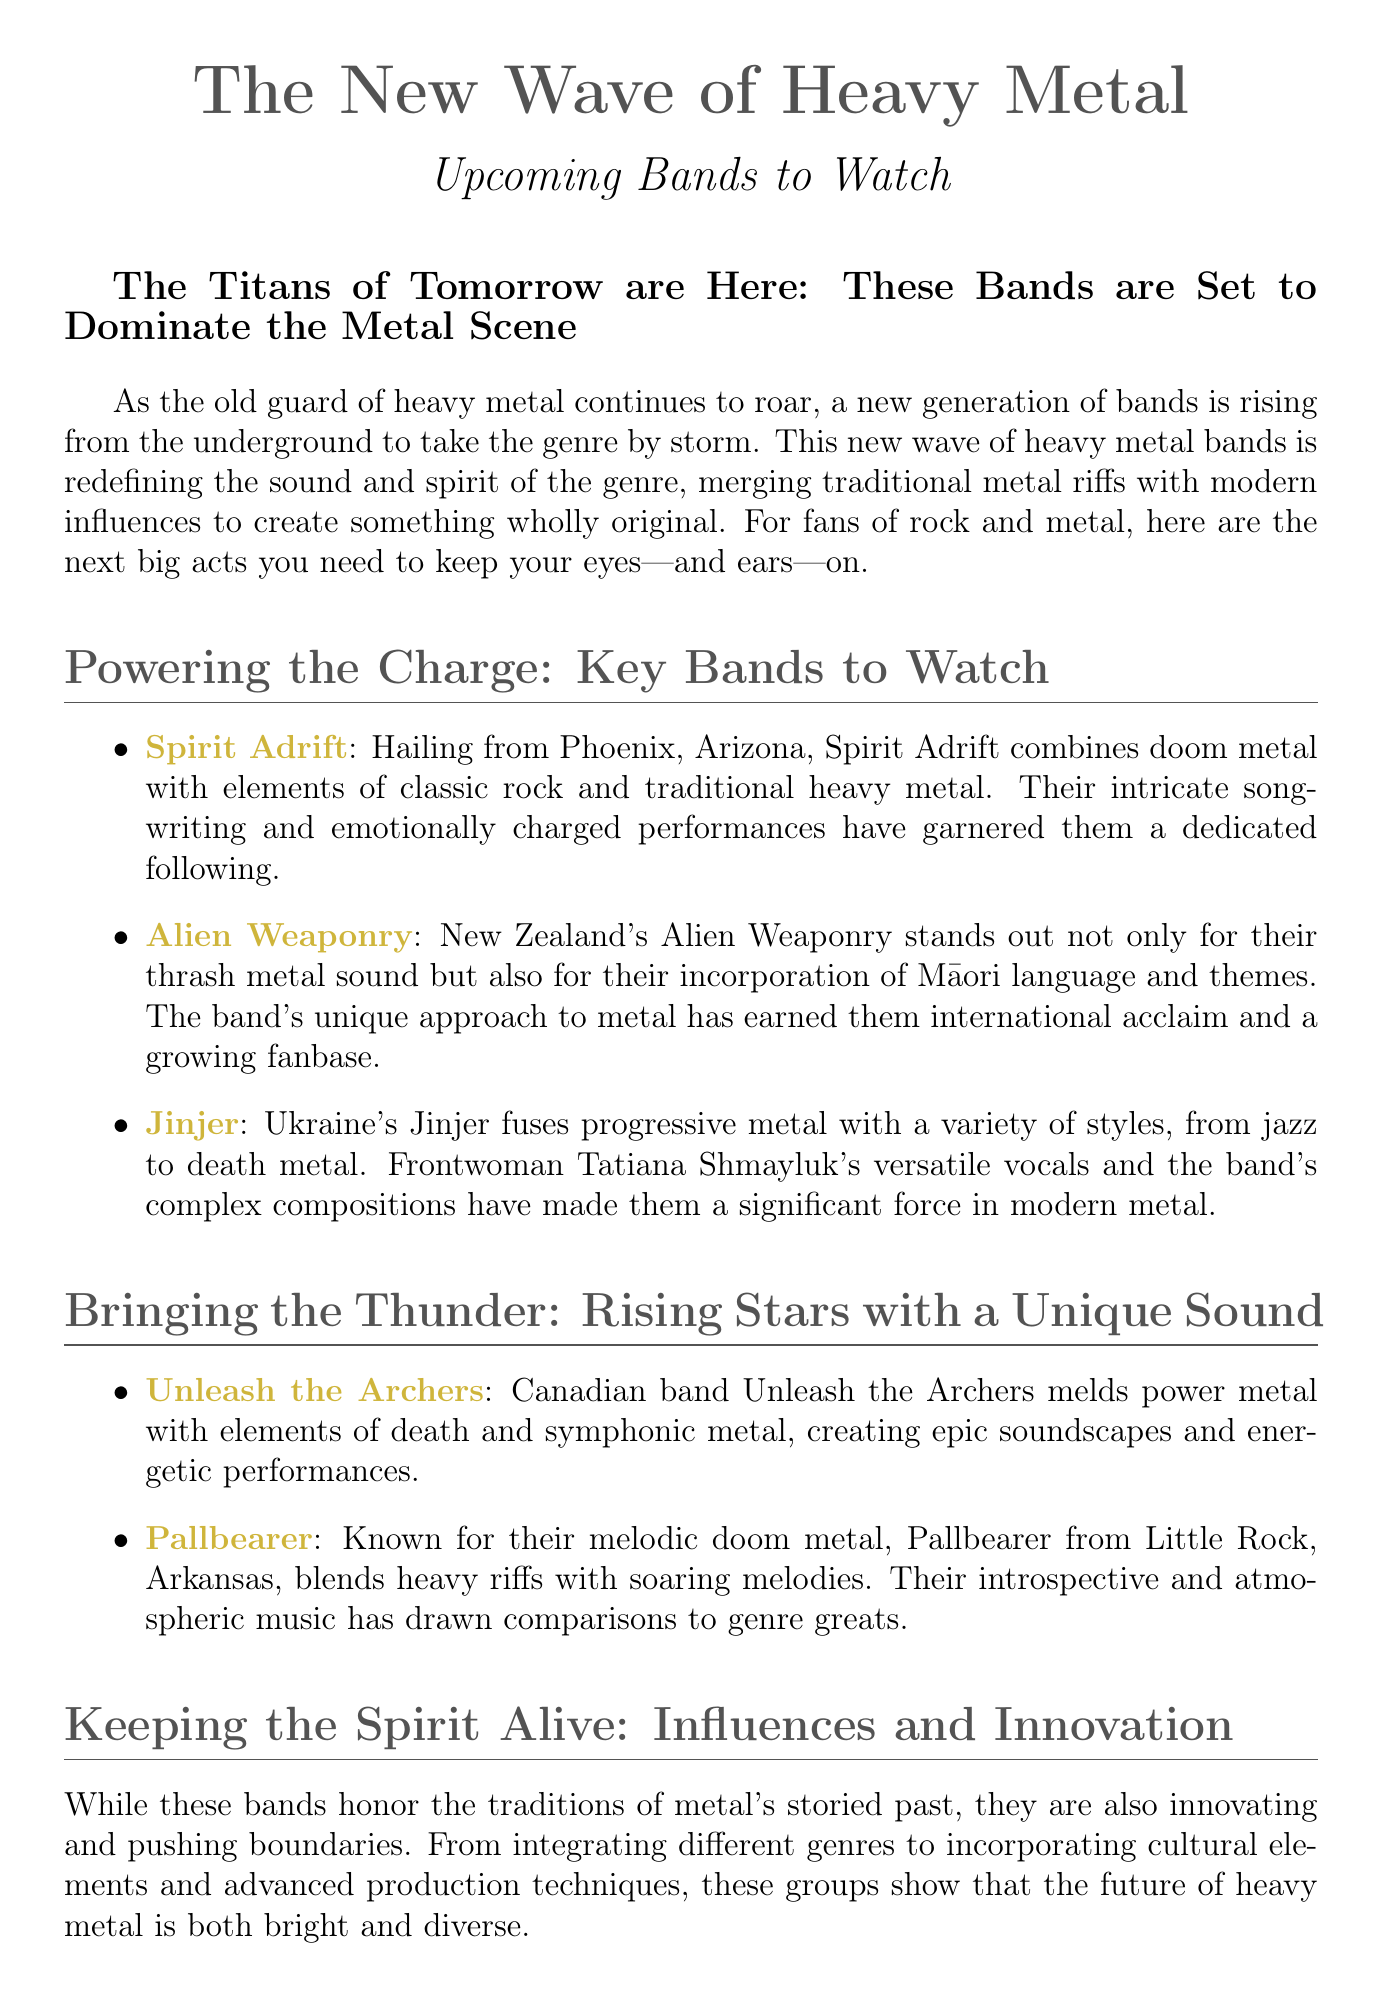What is the title of the press release? The title of the press release is prominently displayed at the top of the document, indicating the focus on the New Wave of Heavy Metal.
Answer: The New Wave of Heavy Metal Which band is mentioned as being from Phoenix, Arizona? The document specifies that Spirit Adrift is hailing from Phoenix, Arizona, making it clear which band is associated with that location.
Answer: Spirit Adrift What genre does Alien Weaponry primarily represent? The press release notes that Alien Weaponry stands out for their thrash metal sound, highlighting the genre they belong to.
Answer: Thrash metal Who is the frontwoman of Jinjer? The document features information about the band's lead vocalist, specifically mentioning her name and role within the group.
Answer: Tatiana Shmayluk Which band is known for melodic doom metal? The press release provides key information on the style of one band, specifically categorizing them by their unique sound within the metal genre.
Answer: Pallbearer What type of sound do Unleash the Archers create? The document describes the sound of Unleash the Archers, indicating their blend of genres that contributes to their musical identity.
Answer: Power metal with elements of death and symphonic metal How does the press release characterize the new wave of heavy metal? The text discusses the new wave and its significance to the genre, emphasizing the themes of innovation and evolution.
Answer: Bright and diverse What elements do these bands incorporate in their sound? The document mentions characteristics that define the new wave, showcasing how the bands are integrating various influences into their music.
Answer: Different genres and cultural elements Who should be contacted for press inquiries? The document includes contact information for press queries, identifying the individual responsible for handling such matters.
Answer: John Doe 